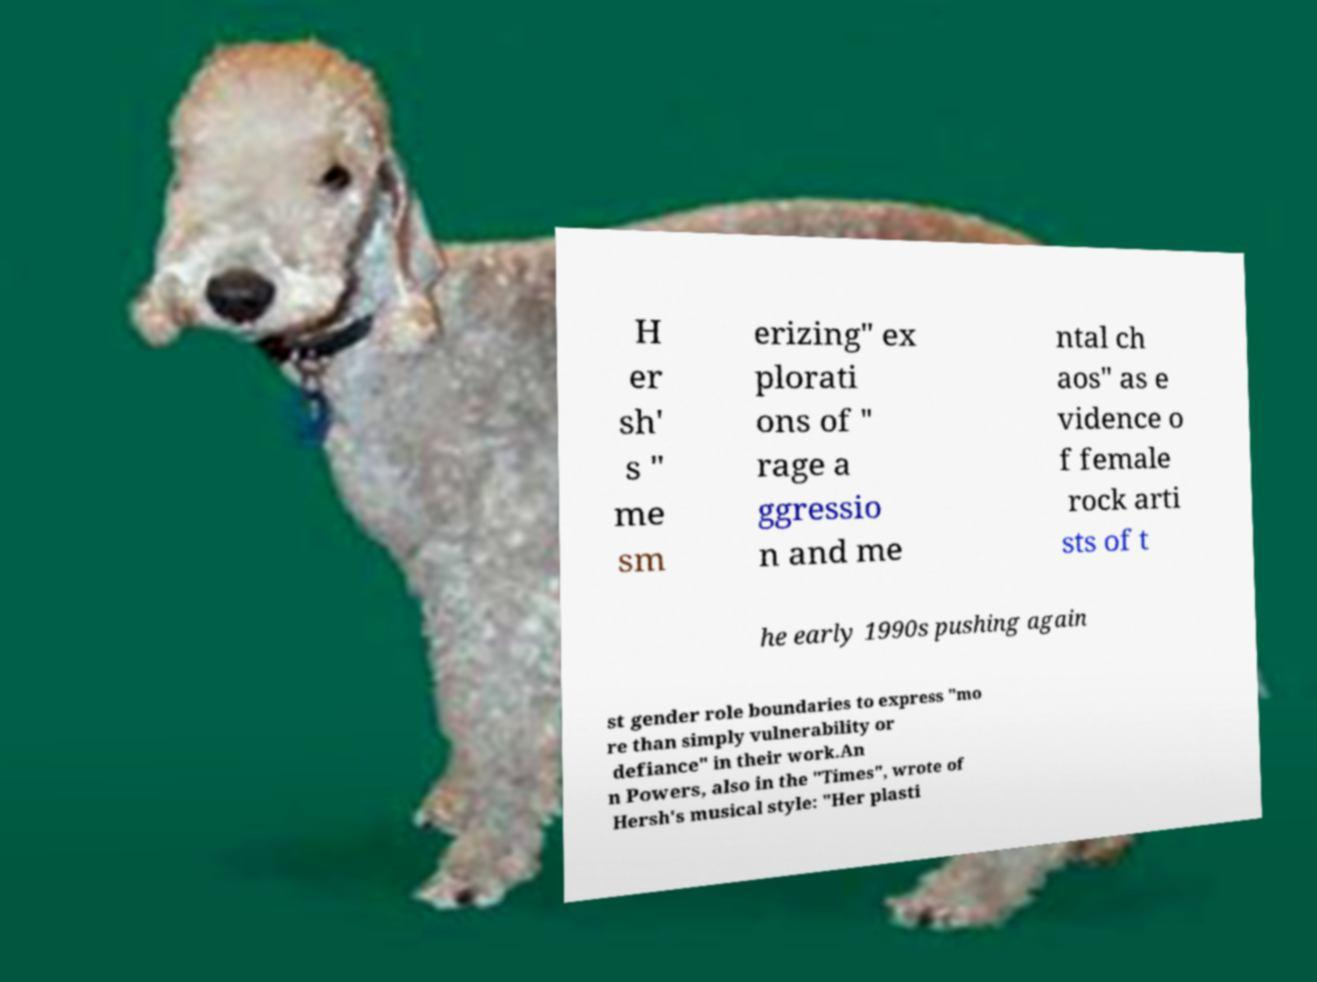Please read and relay the text visible in this image. What does it say? H er sh' s " me sm erizing" ex plorati ons of " rage a ggressio n and me ntal ch aos" as e vidence o f female rock arti sts of t he early 1990s pushing again st gender role boundaries to express "mo re than simply vulnerability or defiance" in their work.An n Powers, also in the "Times", wrote of Hersh's musical style: "Her plasti 